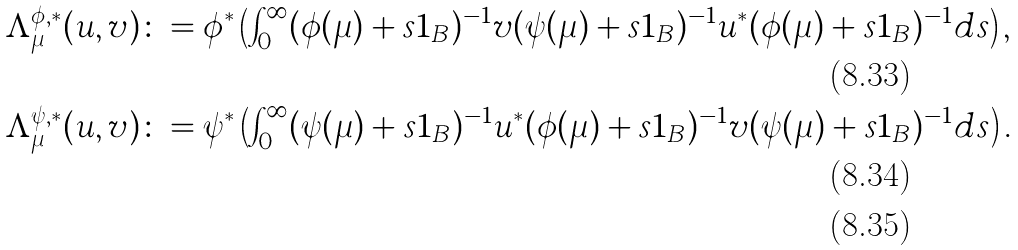Convert formula to latex. <formula><loc_0><loc_0><loc_500><loc_500>\Lambda _ { \mu } ^ { \phi , * } ( u , v ) & \colon = \phi ^ { * } \left ( \int _ { 0 } ^ { \infty } ( \phi ( \mu ) + s 1 _ { B } ) ^ { - 1 } v ( \psi ( \mu ) + s 1 _ { B } ) ^ { - 1 } u ^ { * } ( \phi ( \mu ) + s 1 _ { B } ) ^ { - 1 } d s \right ) , \\ \Lambda _ { \mu } ^ { \psi , * } ( u , v ) & \colon = \psi ^ { * } \left ( \int _ { 0 } ^ { \infty } ( \psi ( \mu ) + s 1 _ { B } ) ^ { - 1 } u ^ { * } ( \phi ( \mu ) + s 1 _ { B } ) ^ { - 1 } v ( \psi ( \mu ) + s 1 _ { B } ) ^ { - 1 } d s \right ) . \\</formula> 